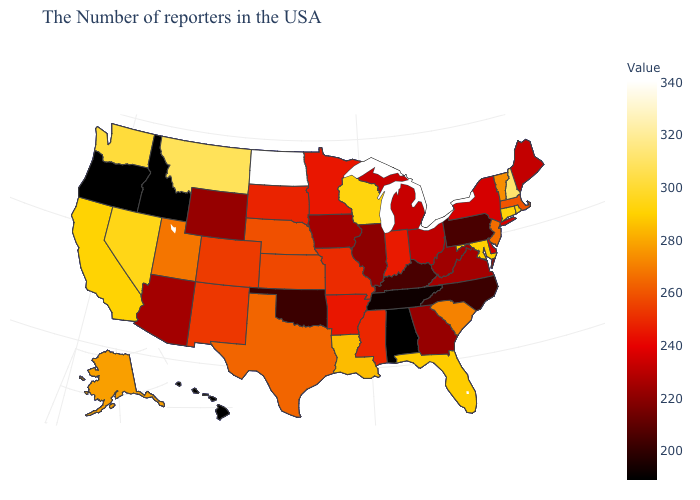Among the states that border California , does Nevada have the highest value?
Be succinct. Yes. Does Alabama have the highest value in the USA?
Short answer required. No. Which states hav the highest value in the Northeast?
Answer briefly. New Hampshire. Which states have the lowest value in the USA?
Concise answer only. Alabama, Idaho, Oregon, Hawaii. Among the states that border Iowa , does Nebraska have the highest value?
Answer briefly. No. Does the map have missing data?
Concise answer only. No. Which states have the lowest value in the USA?
Give a very brief answer. Alabama, Idaho, Oregon, Hawaii. 